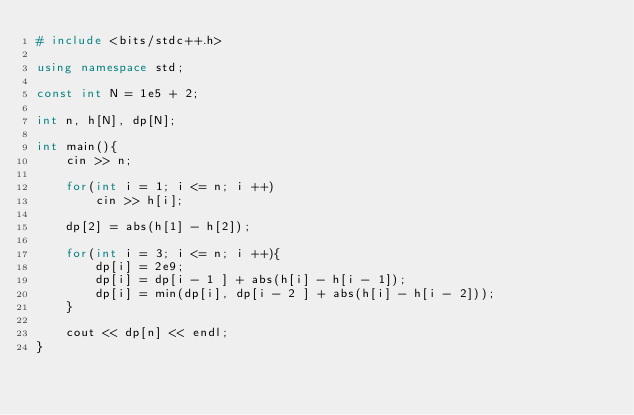Convert code to text. <code><loc_0><loc_0><loc_500><loc_500><_C++_># include <bits/stdc++.h>

using namespace std;

const int N = 1e5 + 2;

int n, h[N], dp[N];

int main(){
    cin >> n;

    for(int i = 1; i <= n; i ++)
        cin >> h[i];

    dp[2] = abs(h[1] - h[2]);   

    for(int i = 3; i <= n; i ++){
        dp[i] = 2e9;
        dp[i] = dp[i - 1 ] + abs(h[i] - h[i - 1]);
        dp[i] = min(dp[i], dp[i - 2 ] + abs(h[i] - h[i - 2]));
    }

    cout << dp[n] << endl;
}
</code> 